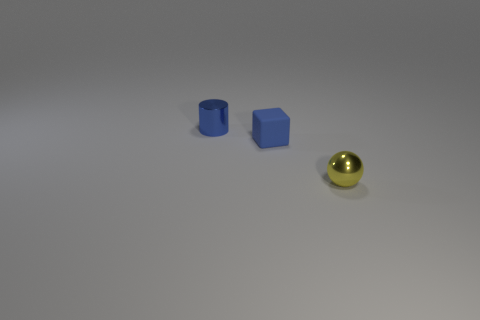Add 3 metallic objects. How many objects exist? 6 Subtract all blocks. How many objects are left? 2 Add 3 small blue metallic objects. How many small blue metallic objects are left? 4 Add 3 tiny green cubes. How many tiny green cubes exist? 3 Subtract 0 red cubes. How many objects are left? 3 Subtract all big red spheres. Subtract all small shiny balls. How many objects are left? 2 